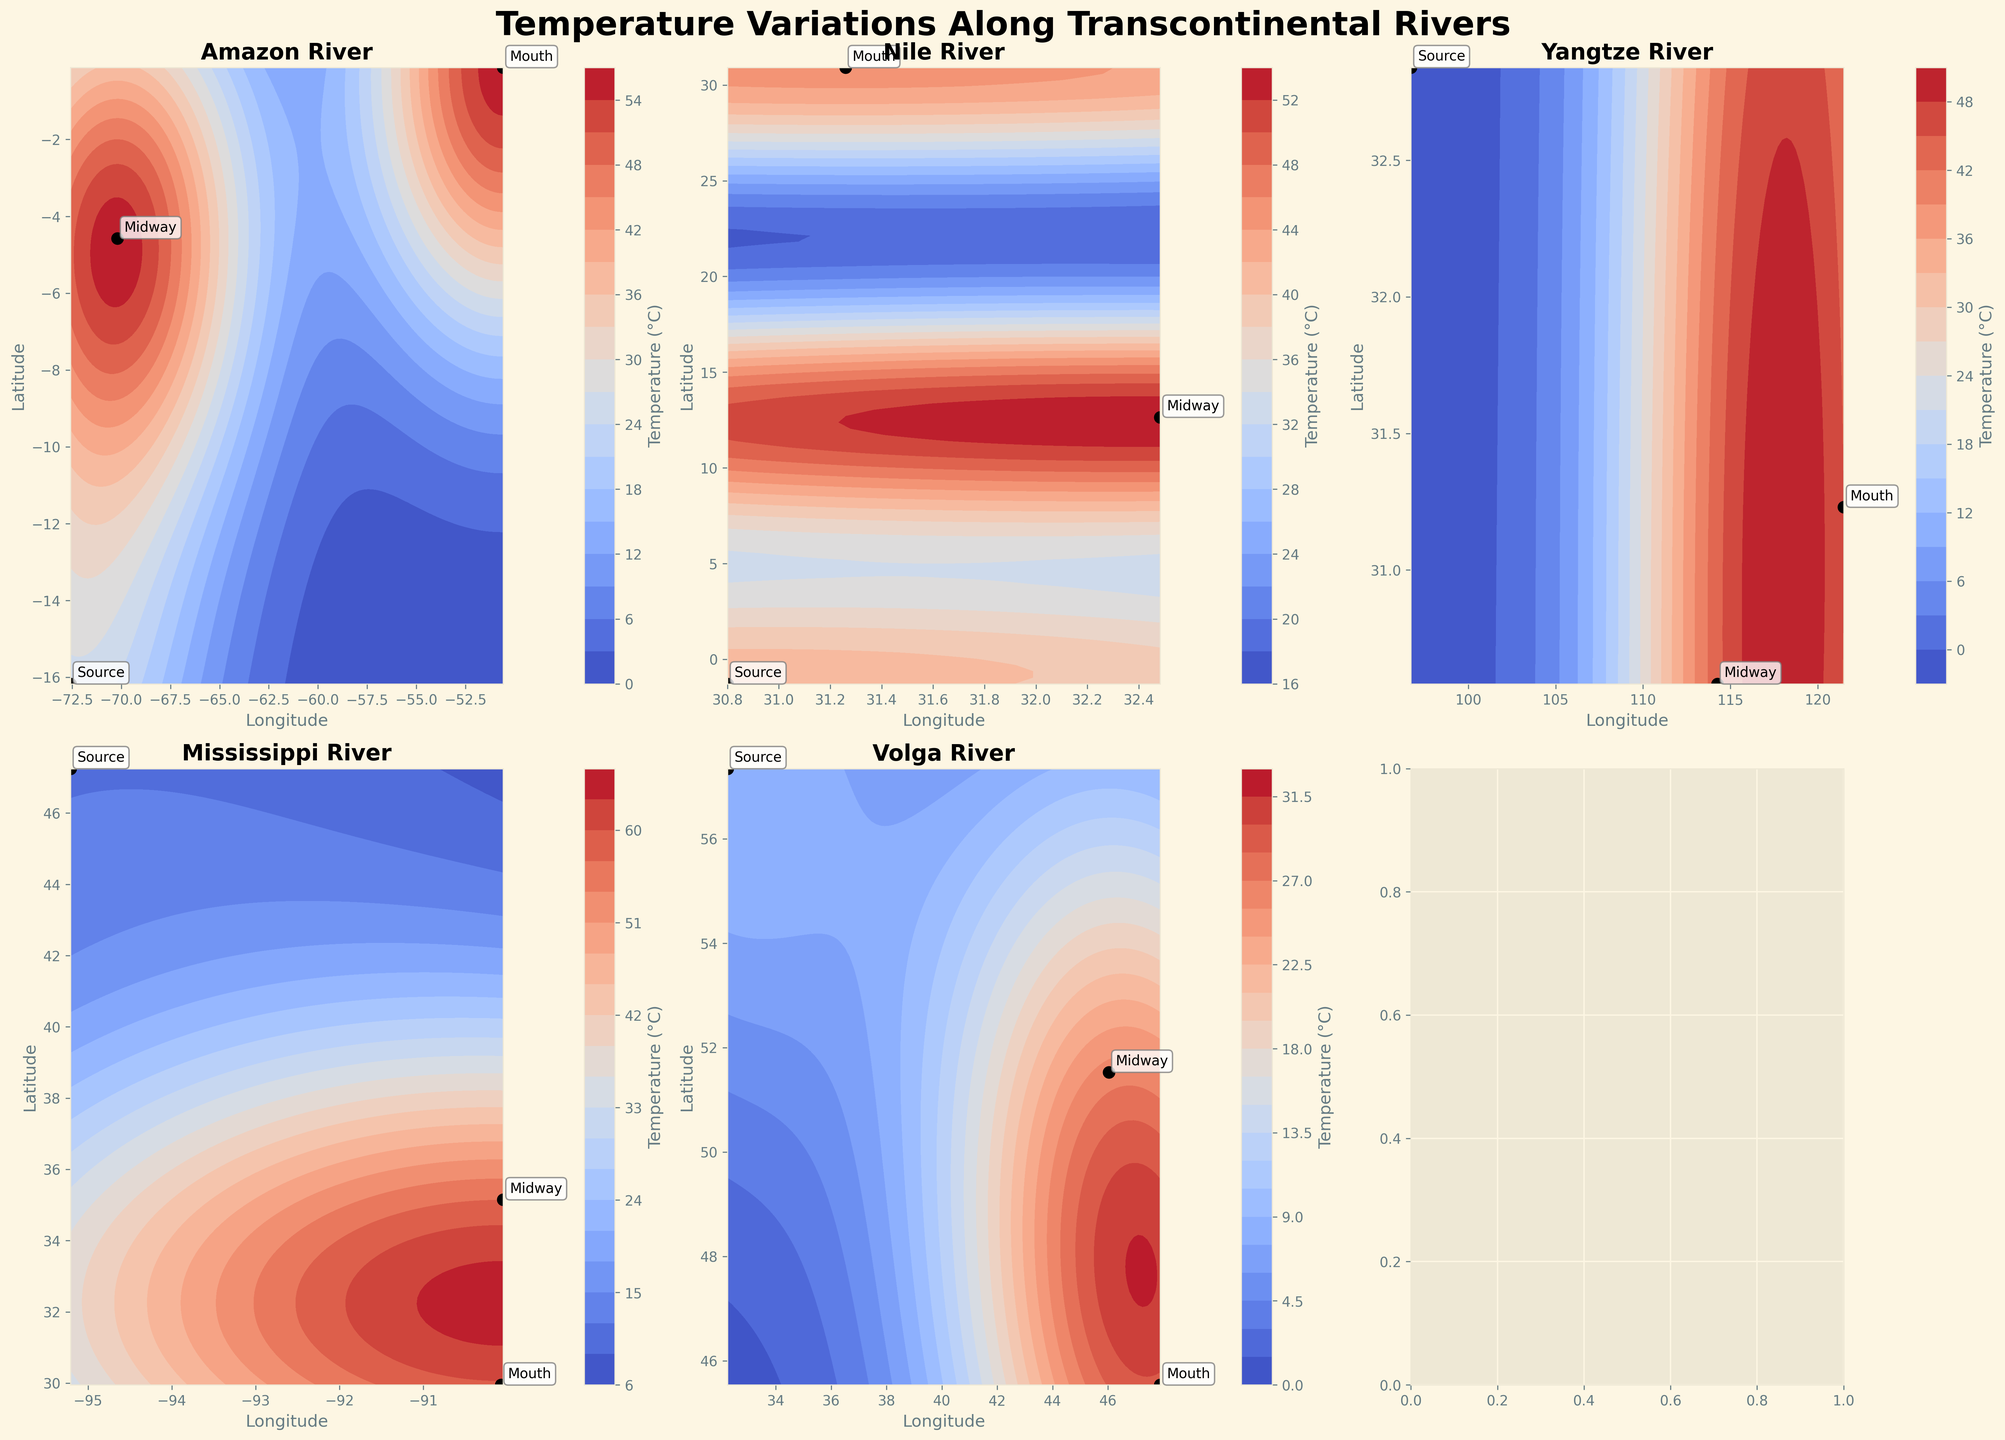What's the temperature at the source of the Amazon River in January? To find the temperature at the source of the Amazon River in January, identify the contour plot for the Amazon River and locate the 'Source' annotation. The corresponding numerical temperature is shown in the contour plot or can be inferred from the plot's legend.
Answer: 10.5°C How does the temperature at the mouth of the Mississippi River compare between January and July? Examine the Mississippi River subplot. Find the 'Mouth' annotation, then compare the temperatures for January and July by locating the corresponding numerals or color gradients in the contour plot's legend.
Answer: January: 10.8°C, July: 29.4°C Which river shows the greatest temperature variation between its midpoint and mouth in July? For each river, compare the temperature values at 'Midway' and 'Mouth' annotations in July. Calculate the differences and identify the river with the largest value.
Answer: Nile What is the average temperature at the source locations of all the rivers in July? Add the temperatures at the source locations for Amazon, Nile, Yangtze, Mississippi, and Volga Rivers in July. Then divide by the number of sources (5).
Answer: (12.1 + 19.7 + 8.2 + 20.5 + 19.5) / 5 = 80.0 / 5 = 16.0°C Which river has the lowest temperature recorded in January and at what location? Review each subplot and identify the lowest temperature in January by examining both the 'Source,' 'Midway,' and 'Mouth' annotations.
Answer: Yangtze River at the Source Compare the temperature difference between the source and mouth of the Yangtze River for both January and July. Identify the temperatures at the 'Source' and 'Mouth' annotations for the Yangtze River in both January and July. Then calculate the differences.
- January: 5.0°C - (-10.5°C) = 15.5°C
- July: 28.7°C - 8.2°C = 20.5°C
Answer: January: 15.5°C, July: 20.5°C What is the contour color used to represent the highest temperature range, and which river and month does it correspond to? Identify the highest temperature range in the contour plot legend. Then find which subplot (river) and month (January or July) corresponds to this highest temperature range by checking the color and the legend.
Answer: Yangtze River in July, deep red color Among the rivers plotted, which one shows the most uniform temperature distribution from source to mouth in January? Analyze each subplot for January. The river with the most uniform temperature distribution will have the least variation in contour colors or values from source to mouth.
Answer: Amazon River 